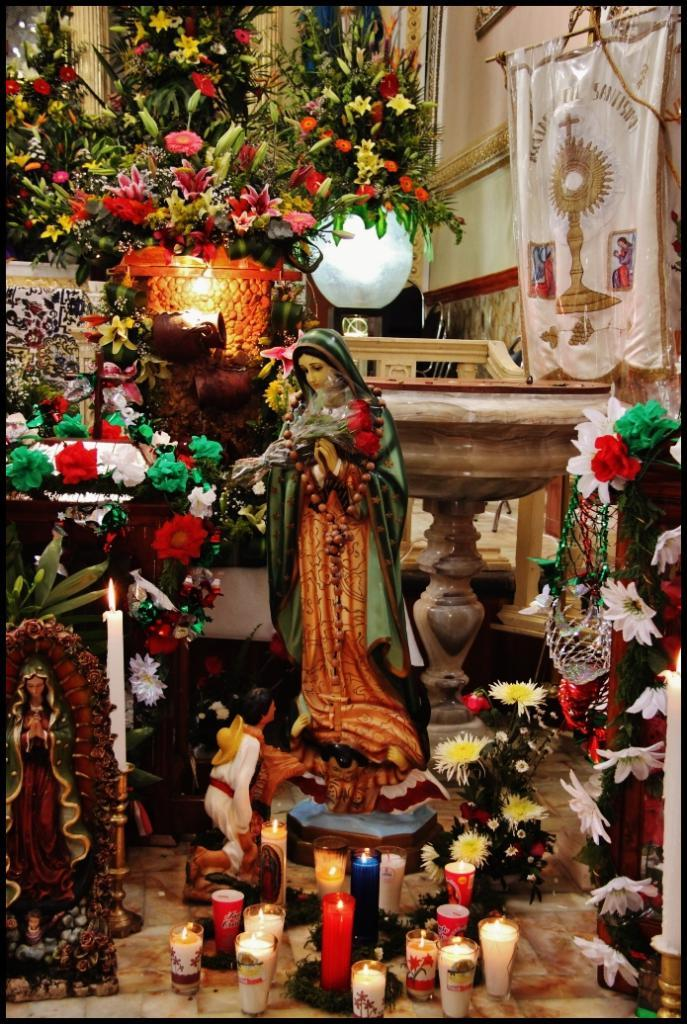What type of objects can be seen in the image? There are miniature statues in the image. Can you describe the placement of any other objects in the image? There are candles on the floor in the image. Where is the cup placed during the party in the image? There is no cup or party present in the image; it only features miniature statues and candles on the floor. 